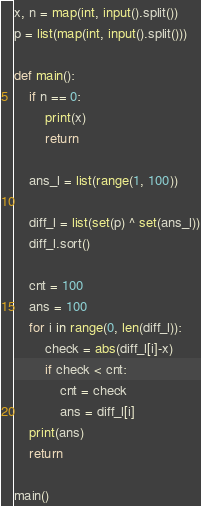Convert code to text. <code><loc_0><loc_0><loc_500><loc_500><_Python_>x, n = map(int, input().split())
p = list(map(int, input().split()))

def main():
    if n == 0:
        print(x)
        return

    ans_l = list(range(1, 100))

    diff_l = list(set(p) ^ set(ans_l))
    diff_l.sort()

    cnt = 100
    ans = 100
    for i in range(0, len(diff_l)):
        check = abs(diff_l[i]-x)
        if check < cnt:
            cnt = check
            ans = diff_l[i]
    print(ans)
    return

main()</code> 